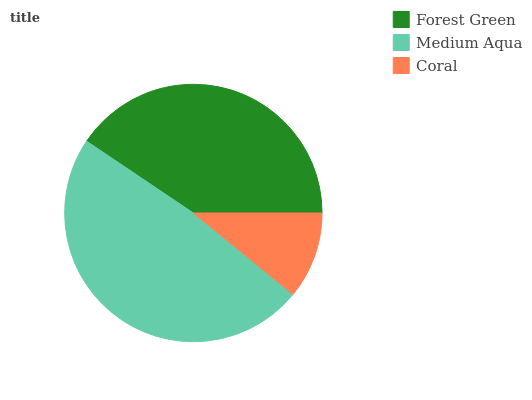Is Coral the minimum?
Answer yes or no. Yes. Is Medium Aqua the maximum?
Answer yes or no. Yes. Is Medium Aqua the minimum?
Answer yes or no. No. Is Coral the maximum?
Answer yes or no. No. Is Medium Aqua greater than Coral?
Answer yes or no. Yes. Is Coral less than Medium Aqua?
Answer yes or no. Yes. Is Coral greater than Medium Aqua?
Answer yes or no. No. Is Medium Aqua less than Coral?
Answer yes or no. No. Is Forest Green the high median?
Answer yes or no. Yes. Is Forest Green the low median?
Answer yes or no. Yes. Is Coral the high median?
Answer yes or no. No. Is Medium Aqua the low median?
Answer yes or no. No. 